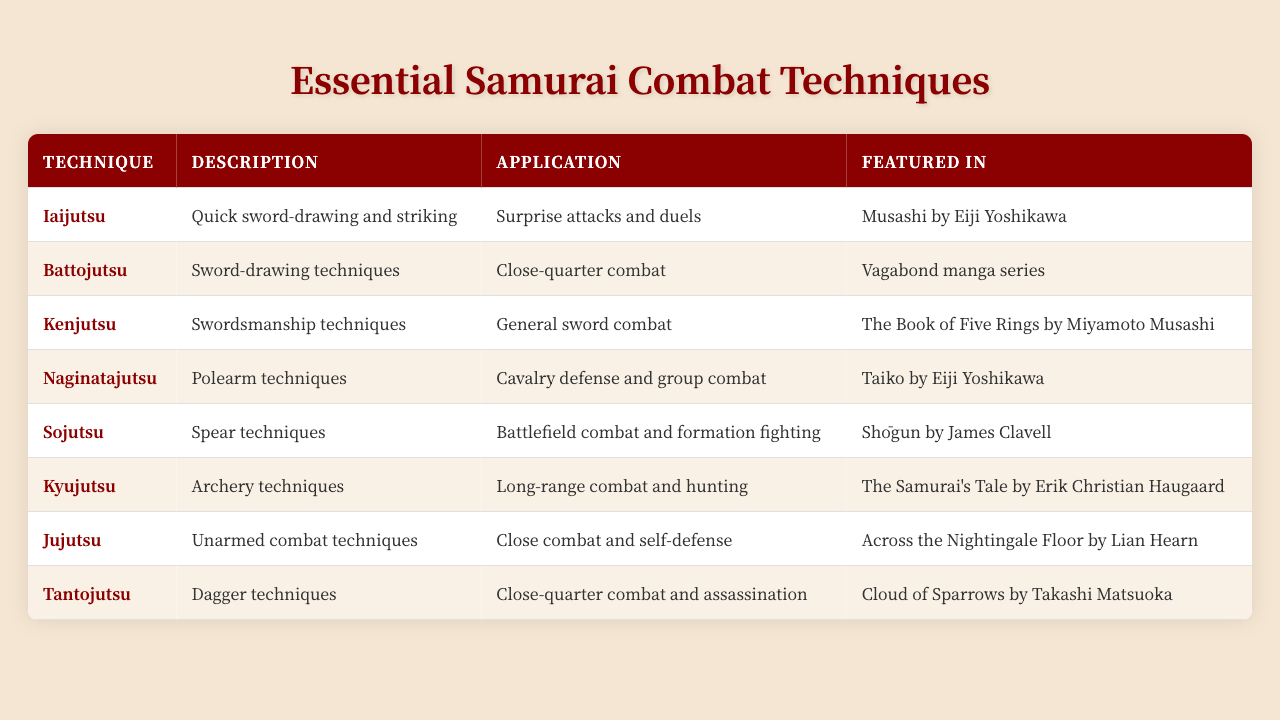What is Iaijutsu used for? Iaijutsu is specifically mentioned in the table for surprise attacks and duels as its application.
Answer: Surprise attacks and duels Which technique specializes in unarmed combat? The table lists Jujutsu as the technique that focuses on unarmed combat techniques.
Answer: Jujutsu How many techniques are featured in the table? The table lists eight techniques of samurai combat, which can be counted from the rows.
Answer: 8 Is Kyujutsu featured in the novel "Shōgun"? The table states that Kyujutsu is featured in "The Samurai's Tale" by Erik Christian Haugaard, not in "Shōgun."
Answer: No Which technique is most commonly applied to close-quarter combat? The table shows that both Jujutsu and Tantojutsu are used for close-quarter combat; however, Jujutsu is specifically mentioned under close combat and self-defense.
Answer: Jujutsu What is the main combat situation for Sojutsu? Sojutsu is designed for battlefield combat and formation fighting, as stated in the application column of the table.
Answer: Battlefield combat and formation fighting Which technique involves polearm techniques? The table identifies Naginatajutsu as the technique that involves polearm techniques.
Answer: Naginatajutsu Name two techniques featured in "Musashi" by Eiji Yoshikawa. The table lists Iaijutsu and Kenjutsu, both of which are cited to be featured in "Musashi."
Answer: Iaijutsu and Kenjutsu What is the difference in application between Iaijutsu and Battojutsu? Iaijutsu is used for surprise attacks and duels, while Battojutsu is specifically for close-quarter combat, demonstrating a focus on strategy versus tactic.
Answer: Surprise attacks and duels vs. close-quarter combat Which technique is associated with assassination tactics? According to the table, Tantojutsu is mentioned as having applications in close-quarter combat and assassination.
Answer: Tantojutsu How many techniques are linked to combat in literature from the Edo period? Analyzing the table, all eight techniques listed relate to various forms of combat, and several are featured in novels set in or inspired by the Edo period.
Answer: 8 